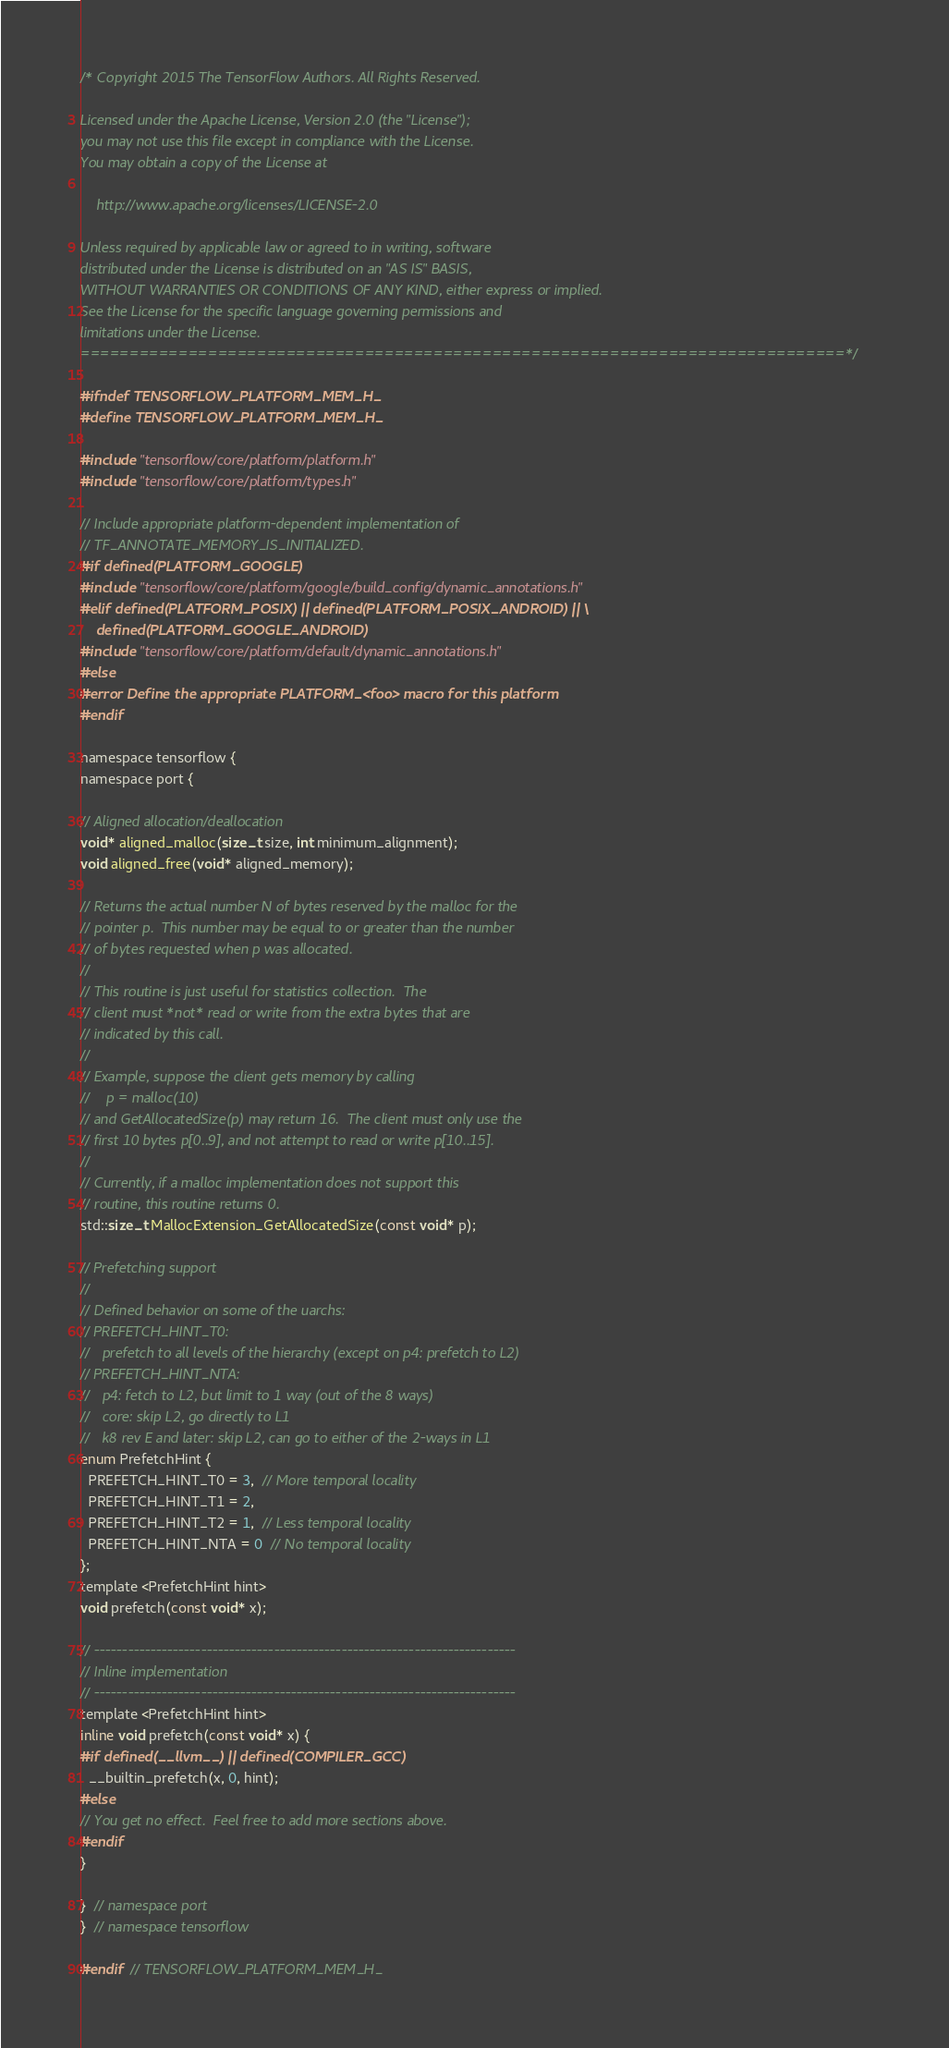<code> <loc_0><loc_0><loc_500><loc_500><_C_>/* Copyright 2015 The TensorFlow Authors. All Rights Reserved.

Licensed under the Apache License, Version 2.0 (the "License");
you may not use this file except in compliance with the License.
You may obtain a copy of the License at

    http://www.apache.org/licenses/LICENSE-2.0

Unless required by applicable law or agreed to in writing, software
distributed under the License is distributed on an "AS IS" BASIS,
WITHOUT WARRANTIES OR CONDITIONS OF ANY KIND, either express or implied.
See the License for the specific language governing permissions and
limitations under the License.
==============================================================================*/

#ifndef TENSORFLOW_PLATFORM_MEM_H_
#define TENSORFLOW_PLATFORM_MEM_H_

#include "tensorflow/core/platform/platform.h"
#include "tensorflow/core/platform/types.h"

// Include appropriate platform-dependent implementation of
// TF_ANNOTATE_MEMORY_IS_INITIALIZED.
#if defined(PLATFORM_GOOGLE)
#include "tensorflow/core/platform/google/build_config/dynamic_annotations.h"
#elif defined(PLATFORM_POSIX) || defined(PLATFORM_POSIX_ANDROID) || \
    defined(PLATFORM_GOOGLE_ANDROID)
#include "tensorflow/core/platform/default/dynamic_annotations.h"
#else
#error Define the appropriate PLATFORM_<foo> macro for this platform
#endif

namespace tensorflow {
namespace port {

// Aligned allocation/deallocation
void* aligned_malloc(size_t size, int minimum_alignment);
void aligned_free(void* aligned_memory);

// Returns the actual number N of bytes reserved by the malloc for the
// pointer p.  This number may be equal to or greater than the number
// of bytes requested when p was allocated.
//
// This routine is just useful for statistics collection.  The
// client must *not* read or write from the extra bytes that are
// indicated by this call.
//
// Example, suppose the client gets memory by calling
//    p = malloc(10)
// and GetAllocatedSize(p) may return 16.  The client must only use the
// first 10 bytes p[0..9], and not attempt to read or write p[10..15].
//
// Currently, if a malloc implementation does not support this
// routine, this routine returns 0.
std::size_t MallocExtension_GetAllocatedSize(const void* p);

// Prefetching support
//
// Defined behavior on some of the uarchs:
// PREFETCH_HINT_T0:
//   prefetch to all levels of the hierarchy (except on p4: prefetch to L2)
// PREFETCH_HINT_NTA:
//   p4: fetch to L2, but limit to 1 way (out of the 8 ways)
//   core: skip L2, go directly to L1
//   k8 rev E and later: skip L2, can go to either of the 2-ways in L1
enum PrefetchHint {
  PREFETCH_HINT_T0 = 3,  // More temporal locality
  PREFETCH_HINT_T1 = 2,
  PREFETCH_HINT_T2 = 1,  // Less temporal locality
  PREFETCH_HINT_NTA = 0  // No temporal locality
};
template <PrefetchHint hint>
void prefetch(const void* x);

// ---------------------------------------------------------------------------
// Inline implementation
// ---------------------------------------------------------------------------
template <PrefetchHint hint>
inline void prefetch(const void* x) {
#if defined(__llvm__) || defined(COMPILER_GCC)
  __builtin_prefetch(x, 0, hint);
#else
// You get no effect.  Feel free to add more sections above.
#endif
}

}  // namespace port
}  // namespace tensorflow

#endif  // TENSORFLOW_PLATFORM_MEM_H_
</code> 